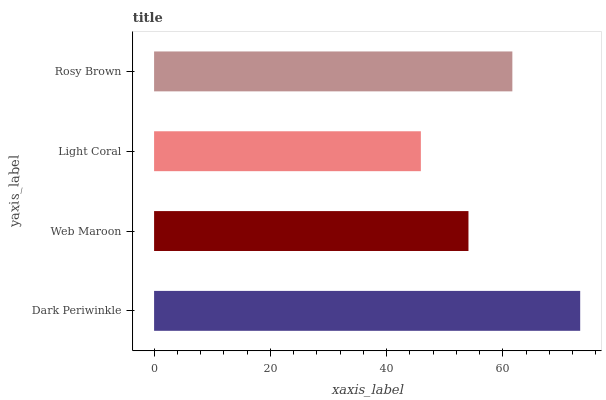Is Light Coral the minimum?
Answer yes or no. Yes. Is Dark Periwinkle the maximum?
Answer yes or no. Yes. Is Web Maroon the minimum?
Answer yes or no. No. Is Web Maroon the maximum?
Answer yes or no. No. Is Dark Periwinkle greater than Web Maroon?
Answer yes or no. Yes. Is Web Maroon less than Dark Periwinkle?
Answer yes or no. Yes. Is Web Maroon greater than Dark Periwinkle?
Answer yes or no. No. Is Dark Periwinkle less than Web Maroon?
Answer yes or no. No. Is Rosy Brown the high median?
Answer yes or no. Yes. Is Web Maroon the low median?
Answer yes or no. Yes. Is Light Coral the high median?
Answer yes or no. No. Is Rosy Brown the low median?
Answer yes or no. No. 